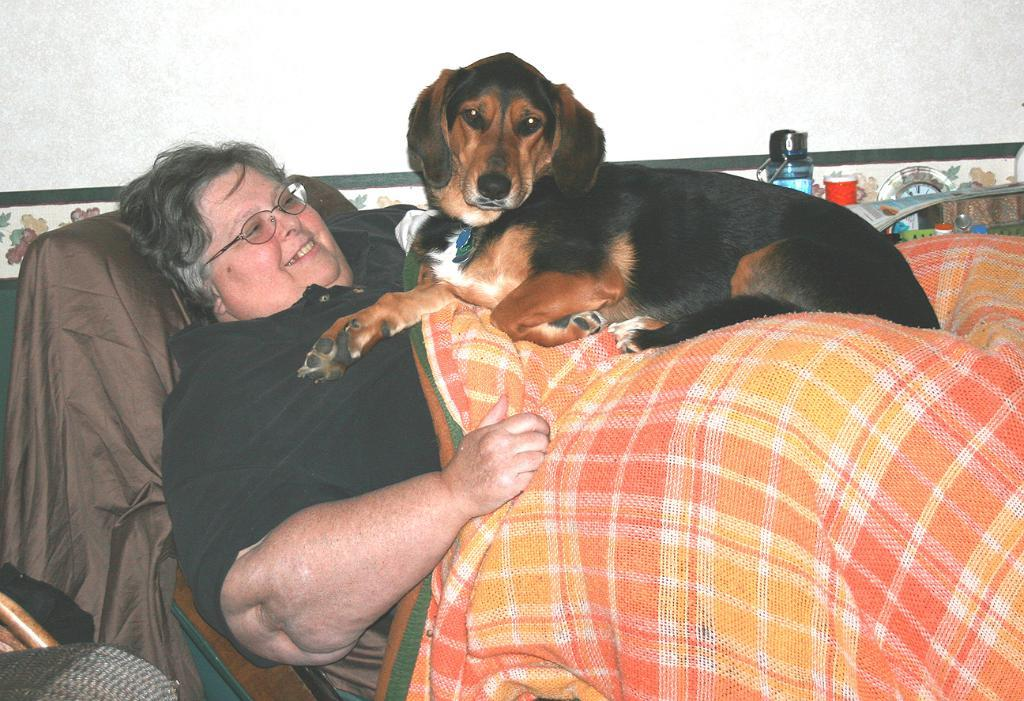Who is present in the image? There is a woman in the image. What is the woman doing in the image? The woman is lying on the bed. Is there any other living creature in the image? Yes, there is a dog on the woman. What is the woman's facial expression in the image? The woman is smiling. What can be seen in the background of the image? There is a wall and a bottle in the background of the image. What type of linen is the woman using to cover herself in the image? There is no mention of linen in the image, as the focus is on the woman, the dog, and the background elements. 